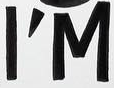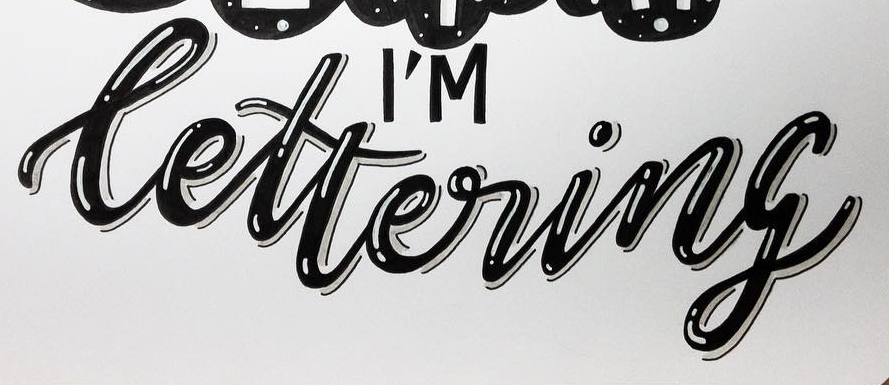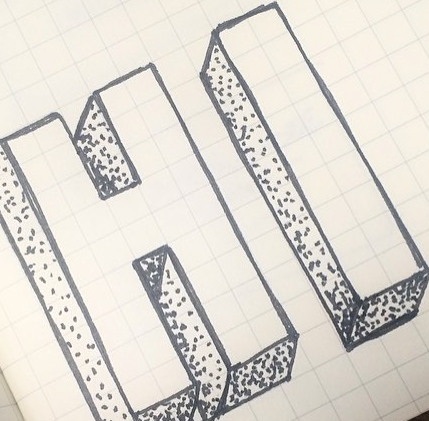Read the text content from these images in order, separated by a semicolon. I'M; lettering; HI 